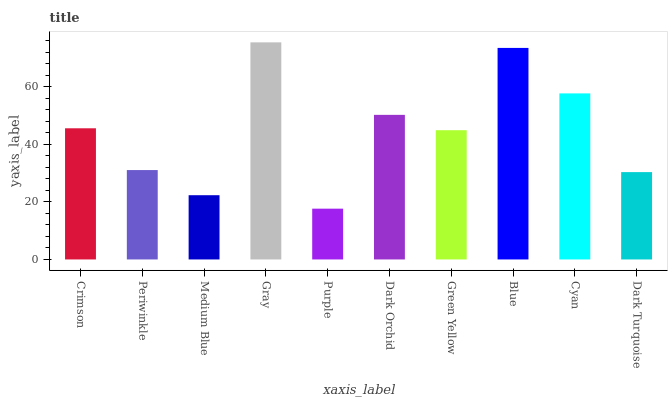Is Purple the minimum?
Answer yes or no. Yes. Is Gray the maximum?
Answer yes or no. Yes. Is Periwinkle the minimum?
Answer yes or no. No. Is Periwinkle the maximum?
Answer yes or no. No. Is Crimson greater than Periwinkle?
Answer yes or no. Yes. Is Periwinkle less than Crimson?
Answer yes or no. Yes. Is Periwinkle greater than Crimson?
Answer yes or no. No. Is Crimson less than Periwinkle?
Answer yes or no. No. Is Crimson the high median?
Answer yes or no. Yes. Is Green Yellow the low median?
Answer yes or no. Yes. Is Cyan the high median?
Answer yes or no. No. Is Dark Orchid the low median?
Answer yes or no. No. 